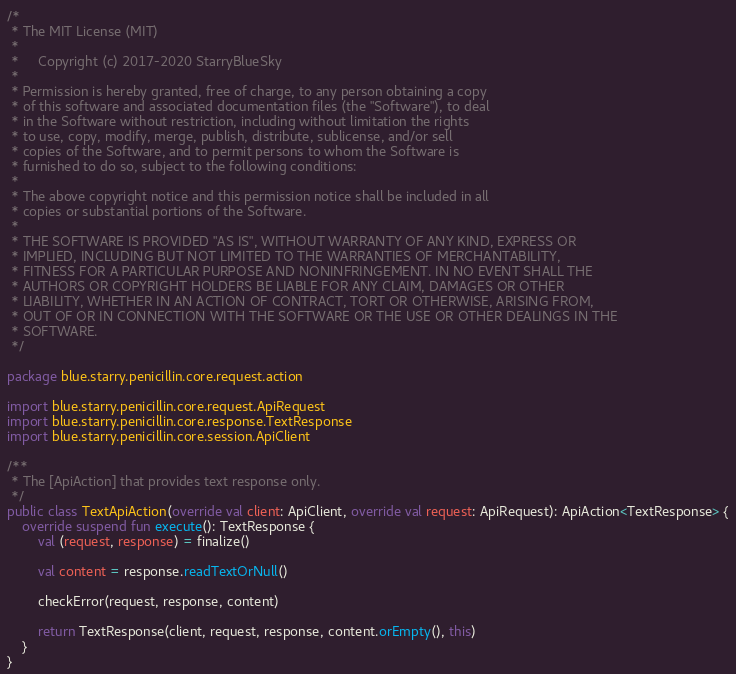Convert code to text. <code><loc_0><loc_0><loc_500><loc_500><_Kotlin_>/*
 * The MIT License (MIT)
 *
 *     Copyright (c) 2017-2020 StarryBlueSky
 *
 * Permission is hereby granted, free of charge, to any person obtaining a copy
 * of this software and associated documentation files (the "Software"), to deal
 * in the Software without restriction, including without limitation the rights
 * to use, copy, modify, merge, publish, distribute, sublicense, and/or sell
 * copies of the Software, and to permit persons to whom the Software is
 * furnished to do so, subject to the following conditions:
 *
 * The above copyright notice and this permission notice shall be included in all
 * copies or substantial portions of the Software.
 *
 * THE SOFTWARE IS PROVIDED "AS IS", WITHOUT WARRANTY OF ANY KIND, EXPRESS OR
 * IMPLIED, INCLUDING BUT NOT LIMITED TO THE WARRANTIES OF MERCHANTABILITY,
 * FITNESS FOR A PARTICULAR PURPOSE AND NONINFRINGEMENT. IN NO EVENT SHALL THE
 * AUTHORS OR COPYRIGHT HOLDERS BE LIABLE FOR ANY CLAIM, DAMAGES OR OTHER
 * LIABILITY, WHETHER IN AN ACTION OF CONTRACT, TORT OR OTHERWISE, ARISING FROM,
 * OUT OF OR IN CONNECTION WITH THE SOFTWARE OR THE USE OR OTHER DEALINGS IN THE
 * SOFTWARE.
 */

package blue.starry.penicillin.core.request.action

import blue.starry.penicillin.core.request.ApiRequest
import blue.starry.penicillin.core.response.TextResponse
import blue.starry.penicillin.core.session.ApiClient

/**
 * The [ApiAction] that provides text response only.
 */
public class TextApiAction(override val client: ApiClient, override val request: ApiRequest): ApiAction<TextResponse> {
    override suspend fun execute(): TextResponse {
        val (request, response) = finalize()

        val content = response.readTextOrNull()

        checkError(request, response, content)

        return TextResponse(client, request, response, content.orEmpty(), this)
    }
}
</code> 